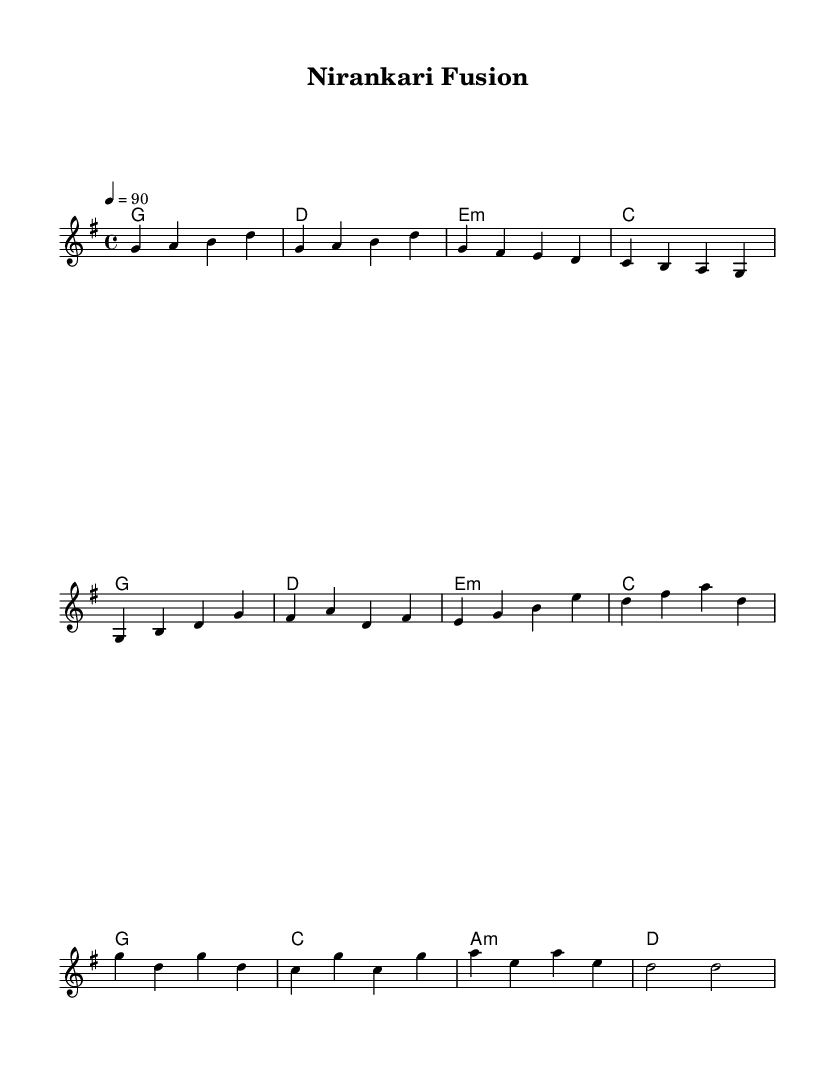What is the key signature of this music? The key signature is G major, which has one sharp (F#). This can be identified by looking at the key signature notation at the beginning of the sheet music.
Answer: G major What is the time signature of this piece? The time signature is 4/4, which indicates that there are four beats per measure and the quarter note gets one beat. The time signature is clearly indicated at the beginning of the score.
Answer: 4/4 What is the tempo marking for the music? The tempo marking is 90 beats per minute, which is specified as "4 = 90" in the tempo notation at the start of the sheet music. This means that each quarter note is to be played at a speed of 90 beats per minute.
Answer: 90 How many measures are in the verse section? The verse section consists of four measures, which can be seen by counting the measures in the section where the melody outlines the verse. Each measure is separated by vertical lines, making it simple to count each measure.
Answer: 4 What type of harmonies are primarily used in this piece? The harmonies primarily consist of major and minor chords, as indicated by the chord symbols shown under the staff. In the chord-mode section, we see major chords like G and C and a minor chord like E minor. This creates a blend typical for uplifting Punjabi folk melodies.
Answer: Major and minor Which sections of the music indicate a shift to the chorus? The shift to the chorus is indicated by a musical contrast in melody and harmony after the verse section, specifically starting with the measures labeled as "Chorus". The transition to these measures generally signifies a change in mood and texture typical in fusion music.
Answer: Chorus What instrument is typically associated with Punjabi folk melodies that might be included in this fusion? The instrument commonly associated with Punjabi folk melodies is the dhol, a traditional drum that adds a rhythmic pulse, complementing the other synthesized sounds and harmonic layers in a fusion context.
Answer: Dhol 